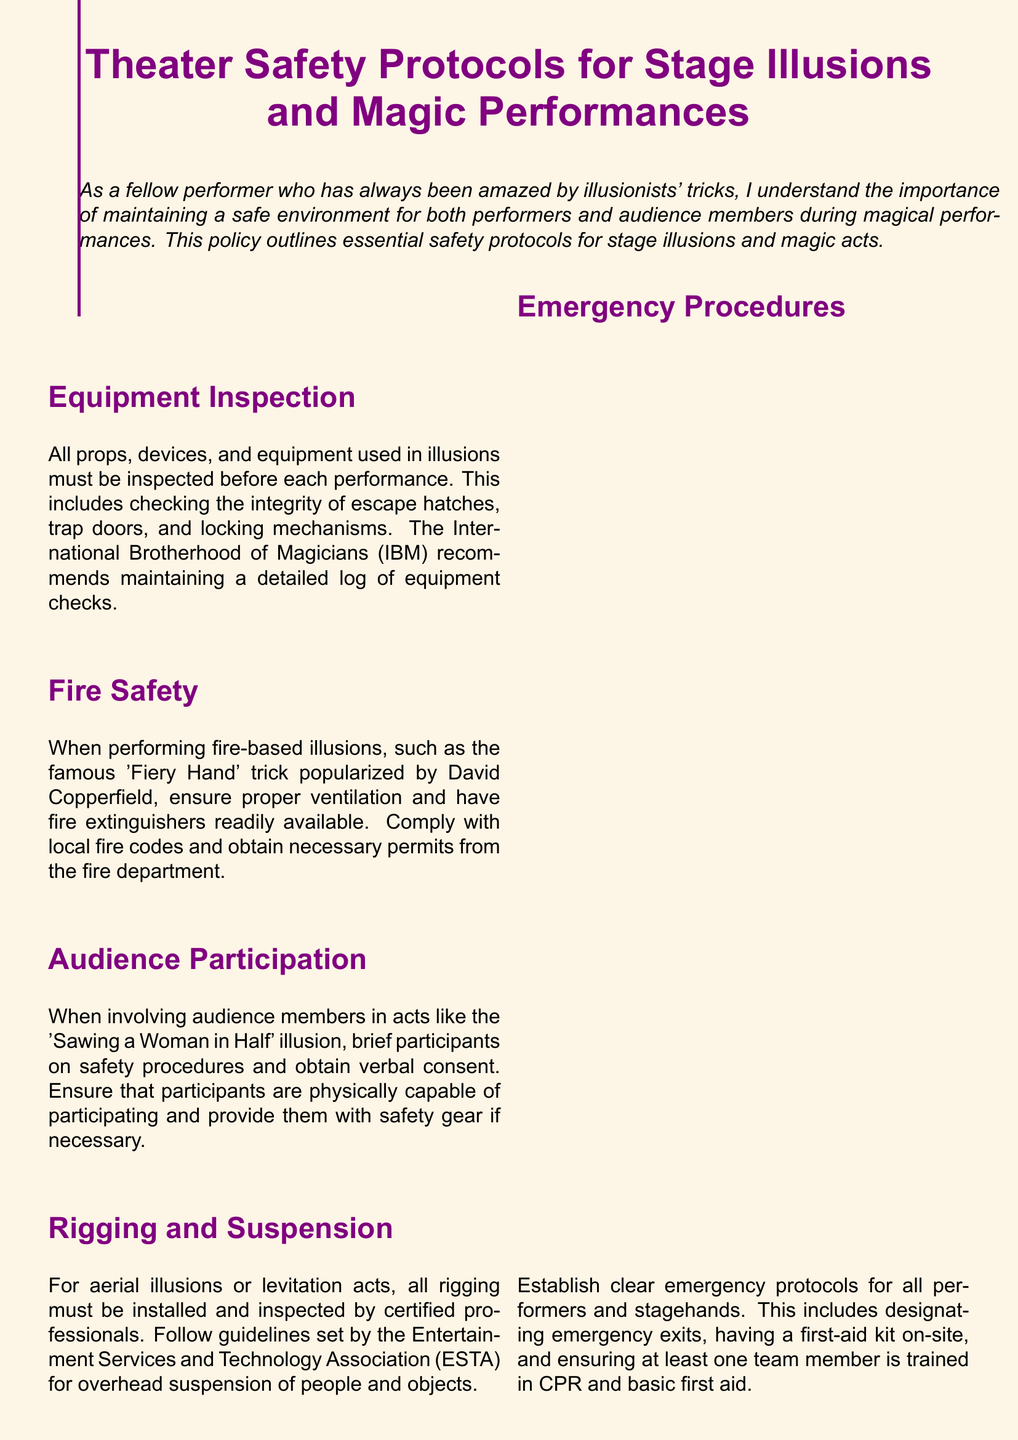What should be inspected before each performance? The document states that all props, devices, and equipment used in illusions must be inspected before each performance.
Answer: Equipment What safety measure is recommended for fire-based illusions? The document emphasizes ensuring proper ventilation and having fire extinguishers readily available for fire-based illusions.
Answer: Proper ventilation and fire extinguishers Who should install and inspect rigging for aerial illusions? It is stated that all rigging must be installed and inspected by certified professionals.
Answer: Certified professionals What must audience participants in magic acts be briefed about? The document mentions that audience participants must be briefed on safety procedures.
Answer: Safety procedures What is the recommended organization for maintaining equipment logs? The International Brotherhood of Magicians (IBM) is recommended for maintaining detailed equipment check logs.
Answer: International Brotherhood of Magicians How many people should be trained in CPR and basic first aid on-site? The policy advises that at least one team member should be trained in CPR and basic first aid.
Answer: At least one What document type is this text classified as? The document specifically outlines safety protocols and procedures related to theater performances.
Answer: Policy document What safety gear should be provided to participants? The document suggests providing safety gear to participants if necessary when involving them in acts.
Answer: Safety gear What is a suggested action when involving audience members? The document states that verbal consent should be obtained from audience members involved in acts.
Answer: Verbal consent 